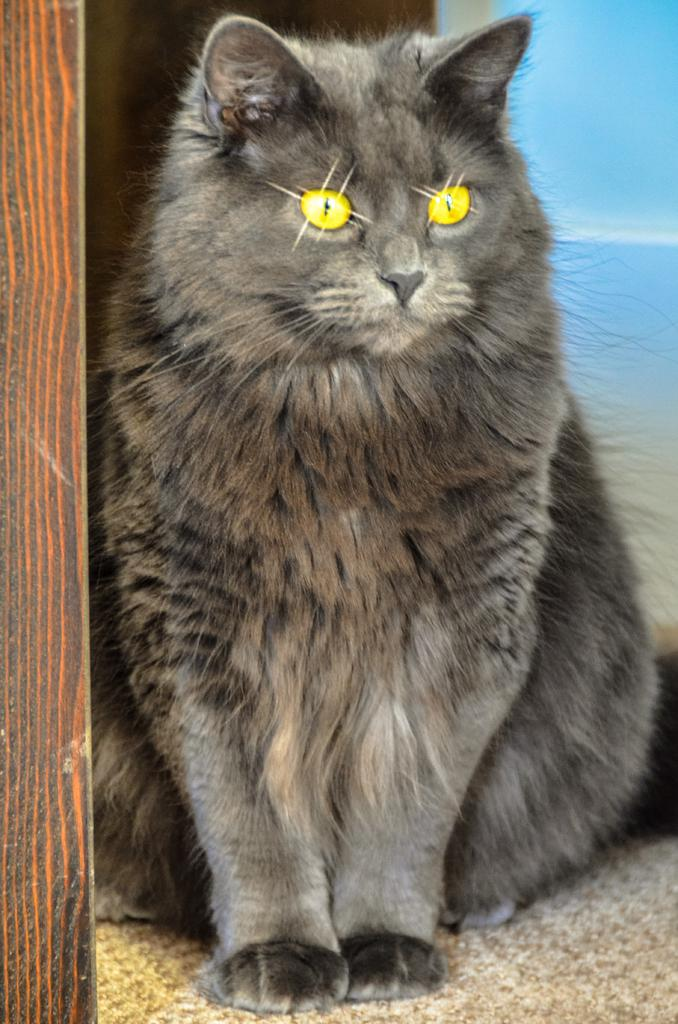What type of animal is in the image? There is a cat in the image. What color are the cat's eyes? The cat has yellow eyes. What type of flooring is visible in the image? There is a carpet in the image. What object can be seen in the image that is made of wood? There is a wooden pole in the image. What color is the background of the image? The background of the image is pale blue in color. Is the cat wearing a crown in the image? No, the cat is not wearing a crown in the image. How many sheep are present in the image? There are no sheep present in the image. 